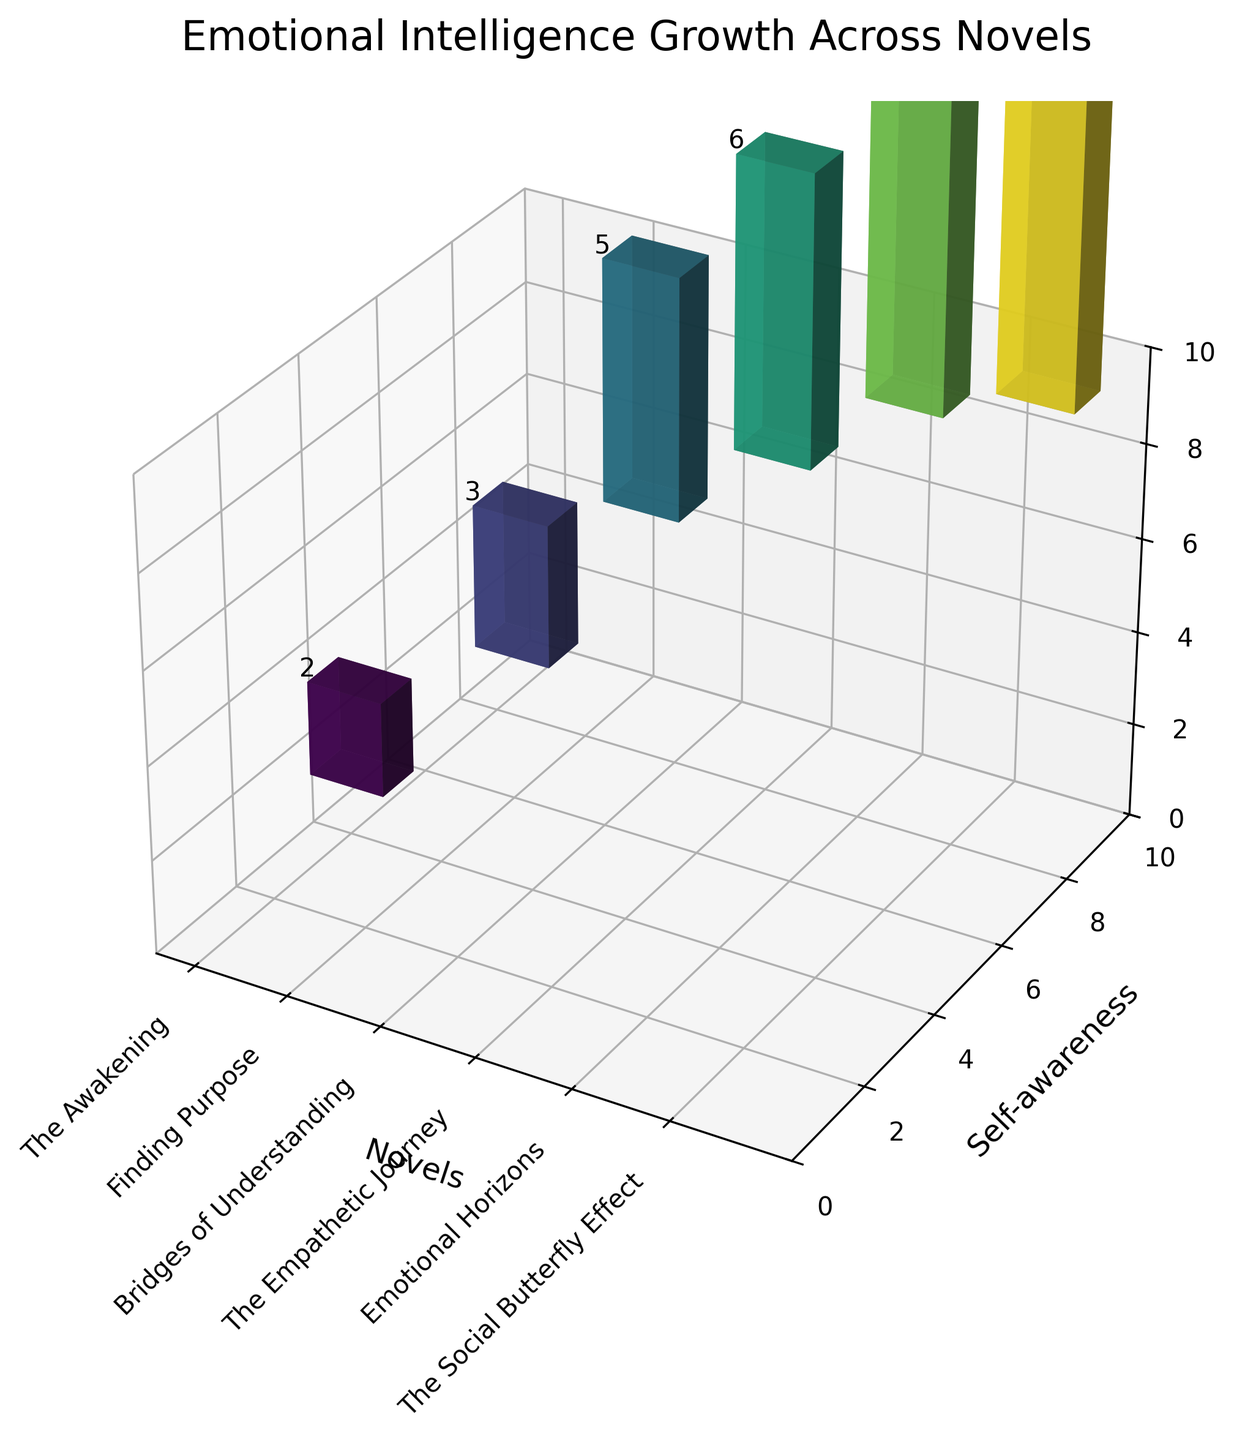How many novels are represented in the figure? We need to count the number of unique novels shown on the x-axis. The figure has six novels displayed: The Awakening, Finding Purpose, Bridges of Understanding, The Empathetic Journey, Emotional Horizons, and The Social Butterfly Effect.
Answer: Six novels What is the title of the figure? The title of the figure is given at the top and clearly states what the figure represents: "Emotional Intelligence Growth Across Novels."
Answer: Emotional Intelligence Growth Across Novels Which novel shows the highest value for social skills? We need to look for the highest bar in terms of social skills (dz) for the novels. The highest value appears over the bar for "The Social Butterfly Effect."
Answer: The Social Butterfly Effect What is the total value of self-awareness across all novels? To find the sum of self-awareness values across all novels, we add the self-awareness values for each novel: 3 + 5 + 6 + 7 + 8 + 9. The final value is 38.
Answer: 38 Between "Bridges of Understanding" and "The Empathetic Journey," which novel has a higher empathy score? Comparing the empathy scores (y-axis values) for "Bridges of Understanding" (7) and "The Empathetic Journey" (8), "The Empathetic Journey" has a higher score.
Answer: The Empathetic Journey What is the average empathy value across all novels? The average value for empathy can be calculated by summing all empathy scores and dividing by the number of novels. The sum is 2 + 4 + 7 + 8 + 9 + 9, which equals 39. Dividing by 6 gives an average of 6.5.
Answer: 6.5 Which two novels have the smallest difference in social skills scores? We look for the smallest difference in social skills values between consecutive bars. "Emotional Horizons" and "The Social Butterfly Effect" both have values of 8 and 9 respectively, so the difference is just 1.
Answer: Emotional Horizons and The Social Butterfly Effect Does the empathy score ever exceed the self-awareness score for any novel? If yes, which ones? We need to check if the empathy (y-axis) values are greater than self-awareness (x-axis) values across any of the novels. The empathy score exceeds self-awareness for "Bridges of Understanding," "The Empathetic Journey," and "Emotional Horizons."
Answer: Yes; Bridges of Understanding, The Empathetic Journey, Emotional Horizons For "Finding Purpose," what is the combined score of self-awareness and empathy? The self-awareness score is 5 and the empathy score is 4. Summing these gives us 5 + 4 = 9.
Answer: 9 Which novel shows the greatest improvement in social skills compared to its preceding novel? We evaluate the increase in social skills (dz) between consecutive novels. The largest increase observed is from "Emotional Horizons" (8) to "The Social Butterfly Effect" (9), an increase of 1, although it's small, it's the highest compared to other intervals.
Answer: The Social Butterfly Effect 